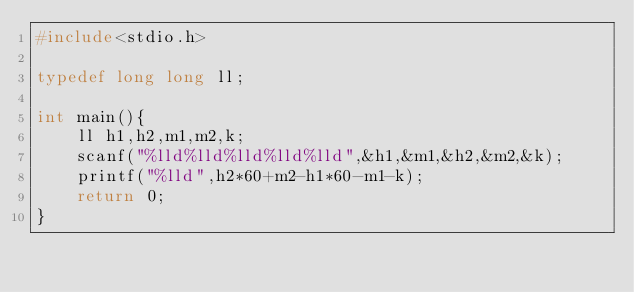<code> <loc_0><loc_0><loc_500><loc_500><_C_>#include<stdio.h>

typedef long long ll;

int main(){
    ll h1,h2,m1,m2,k;
    scanf("%lld%lld%lld%lld%lld",&h1,&m1,&h2,&m2,&k);
    printf("%lld",h2*60+m2-h1*60-m1-k);
    return 0;
}</code> 